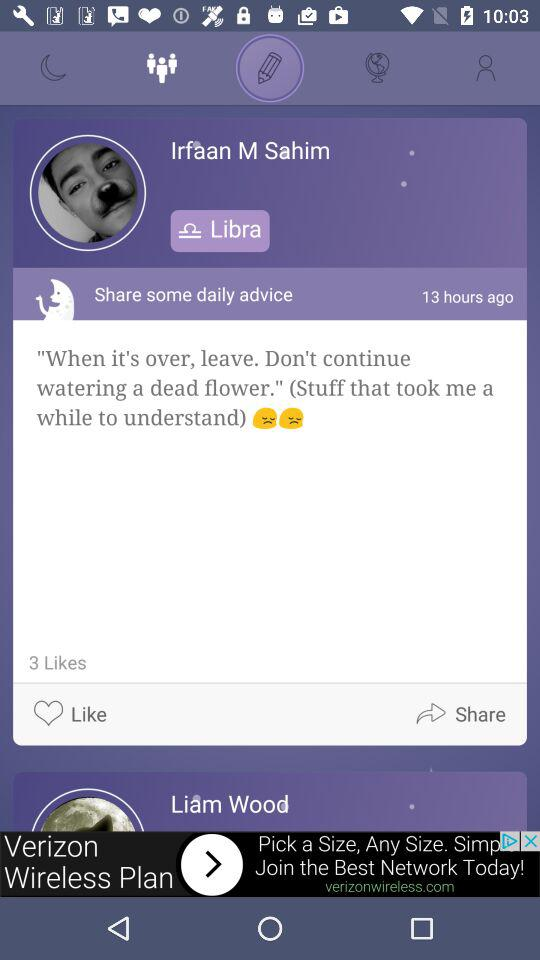How many hours ago was the post posted? It was posted 13 hours ago. 